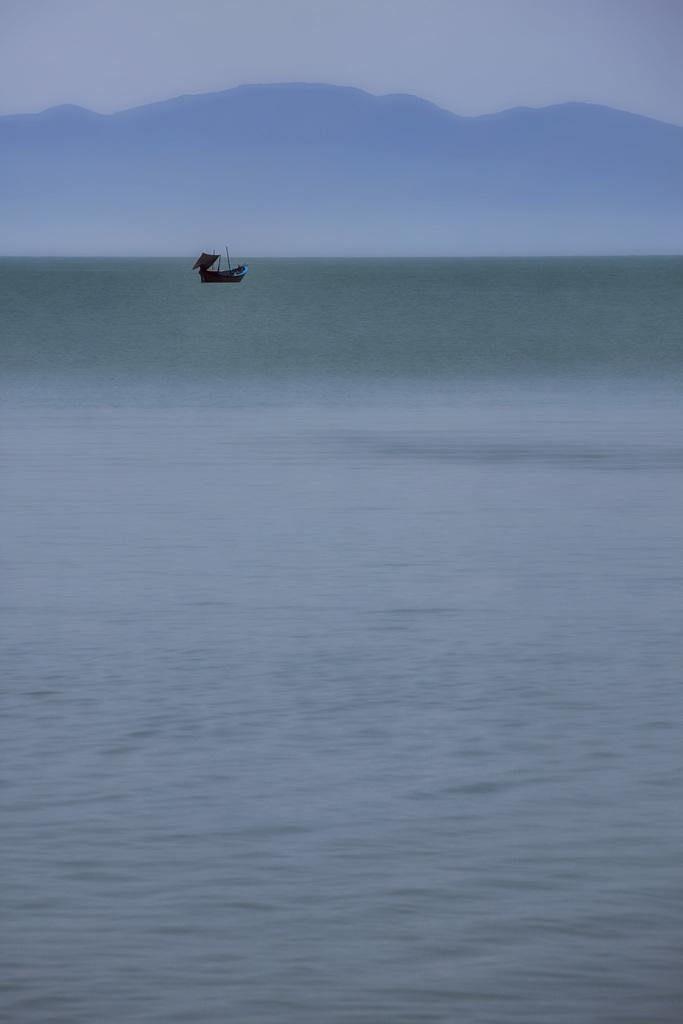What is the main subject of the image? The main subject of the image is water. What is located on the water in the image? There is a boat on the water in the image. What can be seen in the background of the image? There are hills and the sky visible in the background of the image. Where is the volleyball court located in the image? There is no volleyball court present in the image. What type of arch can be seen in the background of the image? There is no arch visible in the background of the image. 